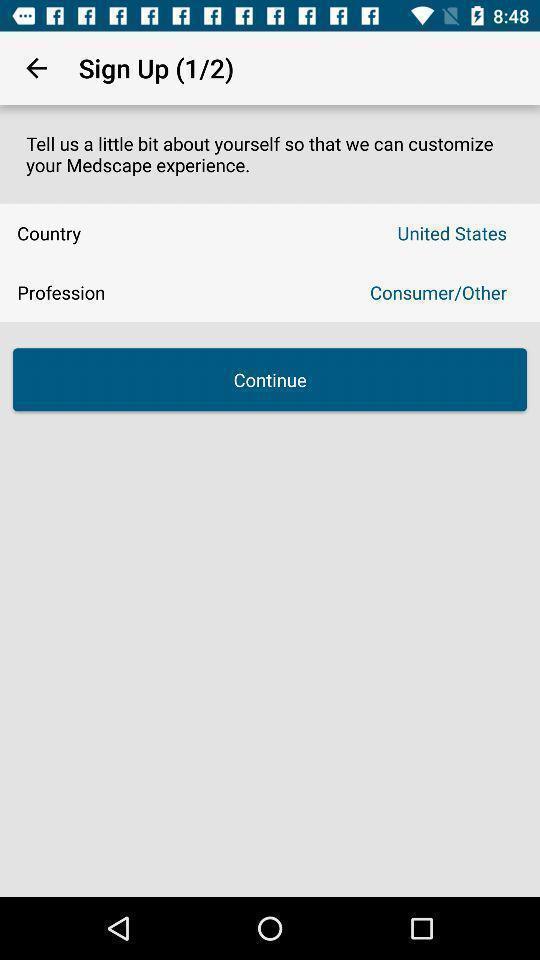Tell me what you see in this picture. Sign up page of a health care app. 